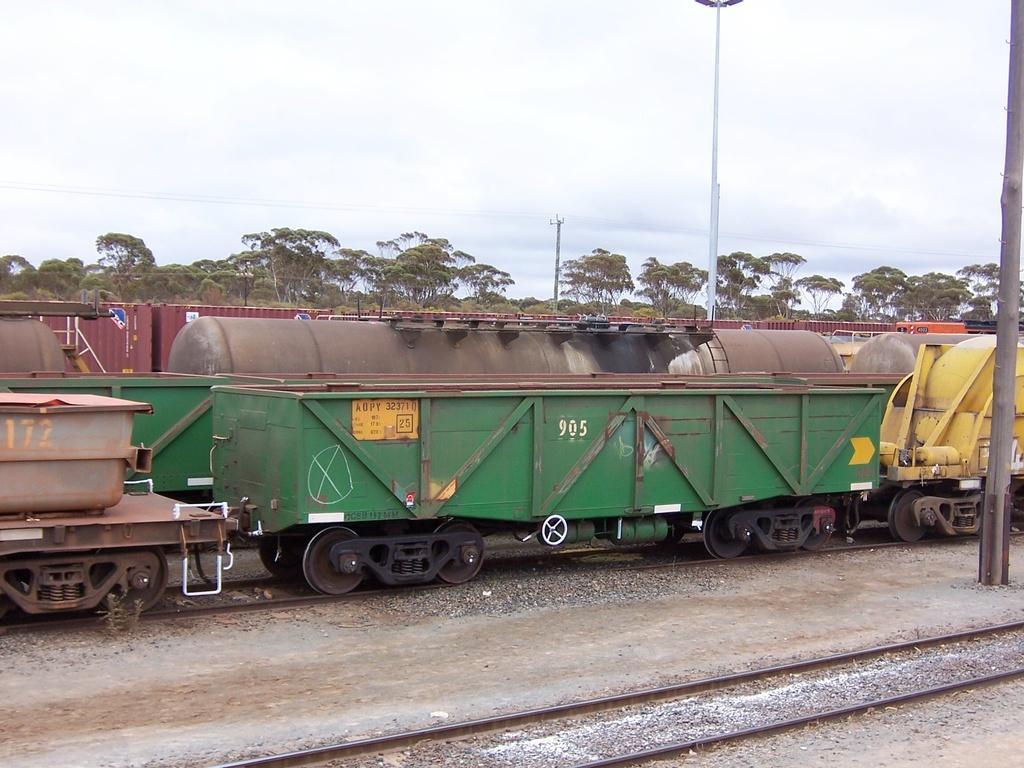In one or two sentences, can you explain what this image depicts? In this image I can see few trains on the railway tracks and they are in different color. Back I can see few trees, poles and the sky is in white and blue color. 